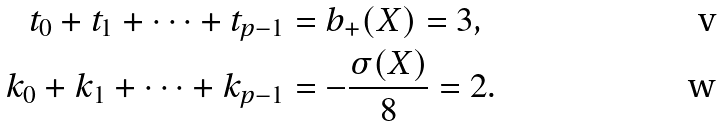<formula> <loc_0><loc_0><loc_500><loc_500>t _ { 0 } + t _ { 1 } + \dots + t _ { p - 1 } & = b _ { + } ( X ) = 3 , \\ k _ { 0 } + k _ { 1 } + \dots + k _ { p - 1 } & = - \frac { \sigma ( X ) } { 8 } = 2 .</formula> 